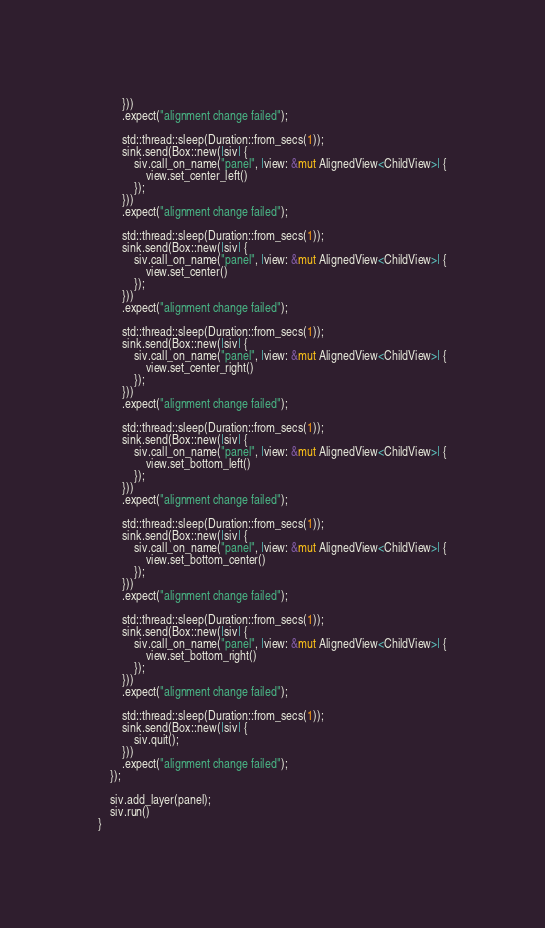Convert code to text. <code><loc_0><loc_0><loc_500><loc_500><_Rust_>        }))
        .expect("alignment change failed");

        std::thread::sleep(Duration::from_secs(1));
        sink.send(Box::new(|siv| {
            siv.call_on_name("panel", |view: &mut AlignedView<ChildView>| {
                view.set_center_left()
            });
        }))
        .expect("alignment change failed");

        std::thread::sleep(Duration::from_secs(1));
        sink.send(Box::new(|siv| {
            siv.call_on_name("panel", |view: &mut AlignedView<ChildView>| {
                view.set_center()
            });
        }))
        .expect("alignment change failed");

        std::thread::sleep(Duration::from_secs(1));
        sink.send(Box::new(|siv| {
            siv.call_on_name("panel", |view: &mut AlignedView<ChildView>| {
                view.set_center_right()
            });
        }))
        .expect("alignment change failed");

        std::thread::sleep(Duration::from_secs(1));
        sink.send(Box::new(|siv| {
            siv.call_on_name("panel", |view: &mut AlignedView<ChildView>| {
                view.set_bottom_left()
            });
        }))
        .expect("alignment change failed");

        std::thread::sleep(Duration::from_secs(1));
        sink.send(Box::new(|siv| {
            siv.call_on_name("panel", |view: &mut AlignedView<ChildView>| {
                view.set_bottom_center()
            });
        }))
        .expect("alignment change failed");

        std::thread::sleep(Duration::from_secs(1));
        sink.send(Box::new(|siv| {
            siv.call_on_name("panel", |view: &mut AlignedView<ChildView>| {
                view.set_bottom_right()
            });
        }))
        .expect("alignment change failed");

        std::thread::sleep(Duration::from_secs(1));
        sink.send(Box::new(|siv| {
            siv.quit();
        }))
        .expect("alignment change failed");
    });

    siv.add_layer(panel);
    siv.run()
}
</code> 